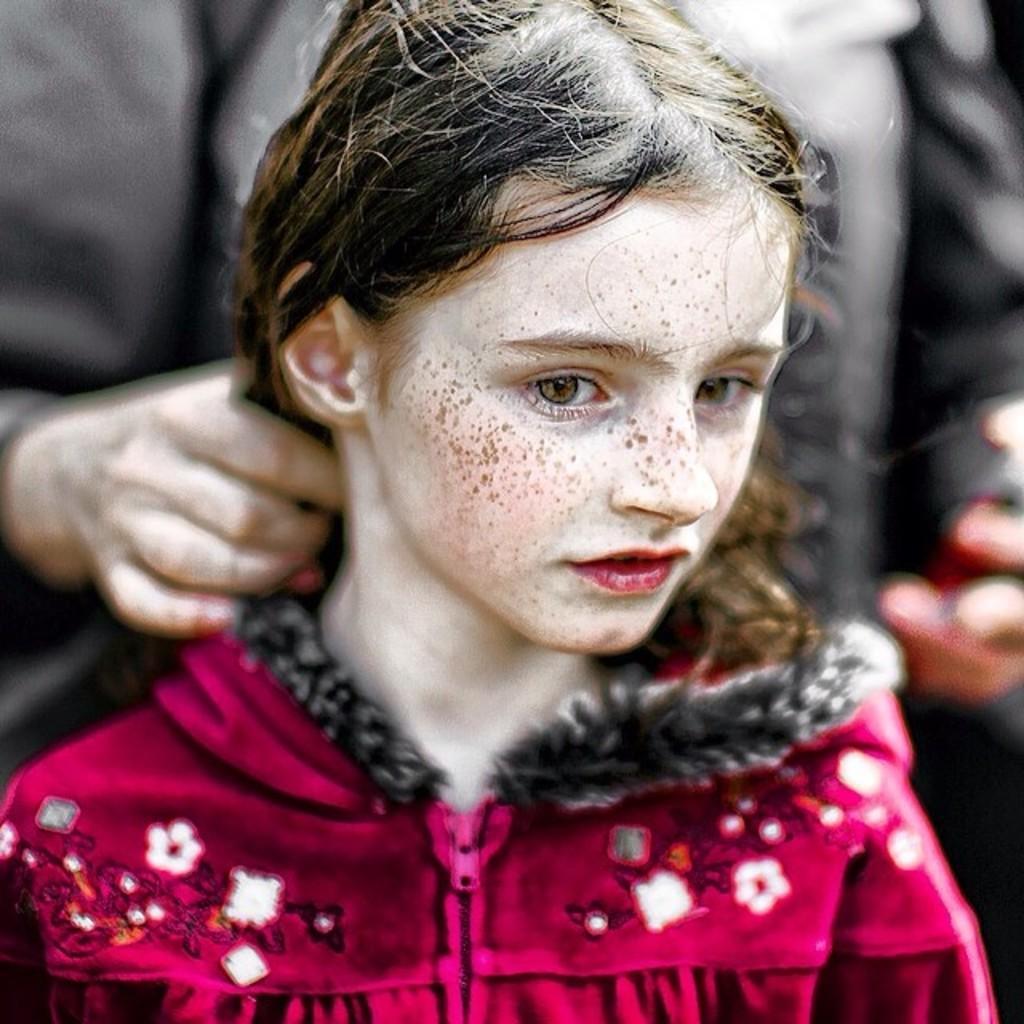Please provide a concise description of this image. In this image we can see one girl in the red dress, one person in the background truncated holding a girl's hair and the background is blurred. 